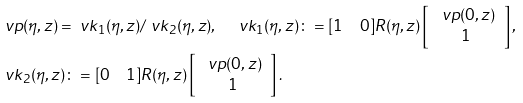<formula> <loc_0><loc_0><loc_500><loc_500>& \ v p ( \eta , z ) = \ v k _ { 1 } ( \eta , z ) / \ v k _ { 2 } ( \eta , z ) , \quad \ v k _ { 1 } ( \eta , z ) \colon = [ 1 \quad 0 ] R ( \eta , z ) \left [ \begin{array} { c } \ v p ( 0 , z ) \\ 1 \end{array} \right ] , \\ & \ v k _ { 2 } ( \eta , z ) \colon = [ 0 \quad 1 ] R ( \eta , z ) \left [ \begin{array} { c } \ v p ( 0 , z ) \\ 1 \end{array} \right ] .</formula> 